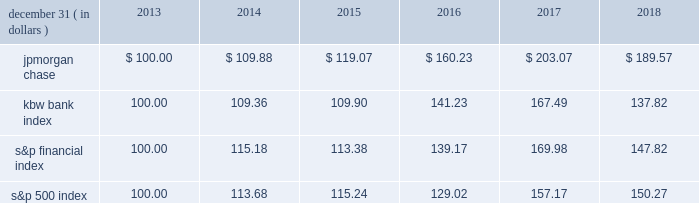Jpmorgan chase & co./2018 form 10-k 41 five-year stock performance the table and graph compare the five-year cumulative total return for jpmorgan chase & co .
( 201cjpmorgan chase 201d or the 201cfirm 201d ) common stock with the cumulative return of the s&p 500 index , the kbw bank index and the s&p financial index .
The s&p 500 index is a commonly referenced equity benchmark in the united states of america ( 201cu.s . 201d ) , consisting of leading companies from different economic sectors .
The kbw bank index seeks to reflect the performance of banks and thrifts that are publicly traded in the u.s .
And is composed of leading national money center and regional banks and thrifts .
The s&p financial index is an index of financial companies , all of which are components of the s&p 500 .
The firm is a component of all three industry indices .
The table and graph assume simultaneous investments of $ 100 on december 31 , 2013 , in jpmorgan chase common stock and in each of the above indices .
The comparison assumes that all dividends are reinvested .
December 31 , ( in dollars ) 2013 2014 2015 2016 2017 2018 .
December 31 , ( in dollars ) .
What is the estimated variation between the percentual decrease observed in the s&p 500 index and in the jpmorgan chase during the years 2017 and 2018? 
Rationale: its the difference between the percentual variations of each indices during 2017 and 2018 .
Computations: ((1 - (189.57 / 203.07)) - (1 - (150.27 / 157.17)))
Answer: 0.02258. 